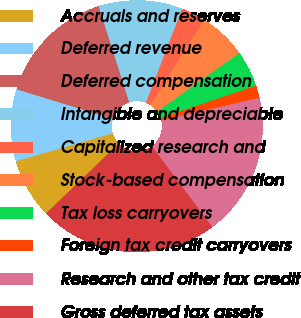Convert chart to OTSL. <chart><loc_0><loc_0><loc_500><loc_500><pie_chart><fcel>Accruals and reserves<fcel>Deferred revenue<fcel>Deferred compensation<fcel>Intangible and depreciable<fcel>Capitalized research and<fcel>Stock-based compensation<fcel>Tax loss carryovers<fcel>Foreign tax credit carryovers<fcel>Research and other tax credit<fcel>Gross deferred tax assets<nl><fcel>7.7%<fcel>9.23%<fcel>15.36%<fcel>10.77%<fcel>3.11%<fcel>6.17%<fcel>4.64%<fcel>1.58%<fcel>18.42%<fcel>23.02%<nl></chart> 